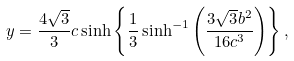<formula> <loc_0><loc_0><loc_500><loc_500>y = \frac { 4 \sqrt { 3 } } { 3 } c \sinh \left \{ \frac { 1 } { 3 } \sinh ^ { - 1 } \left ( \frac { 3 \sqrt { 3 } b ^ { 2 } } { 1 6 c ^ { 3 } } \right ) \right \} ,</formula> 